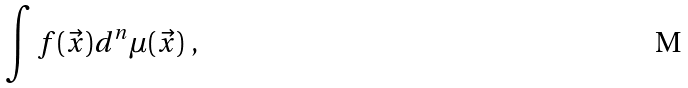Convert formula to latex. <formula><loc_0><loc_0><loc_500><loc_500>\int f ( \vec { x } ) d ^ { n } \mu ( \vec { x } ) \ ,</formula> 